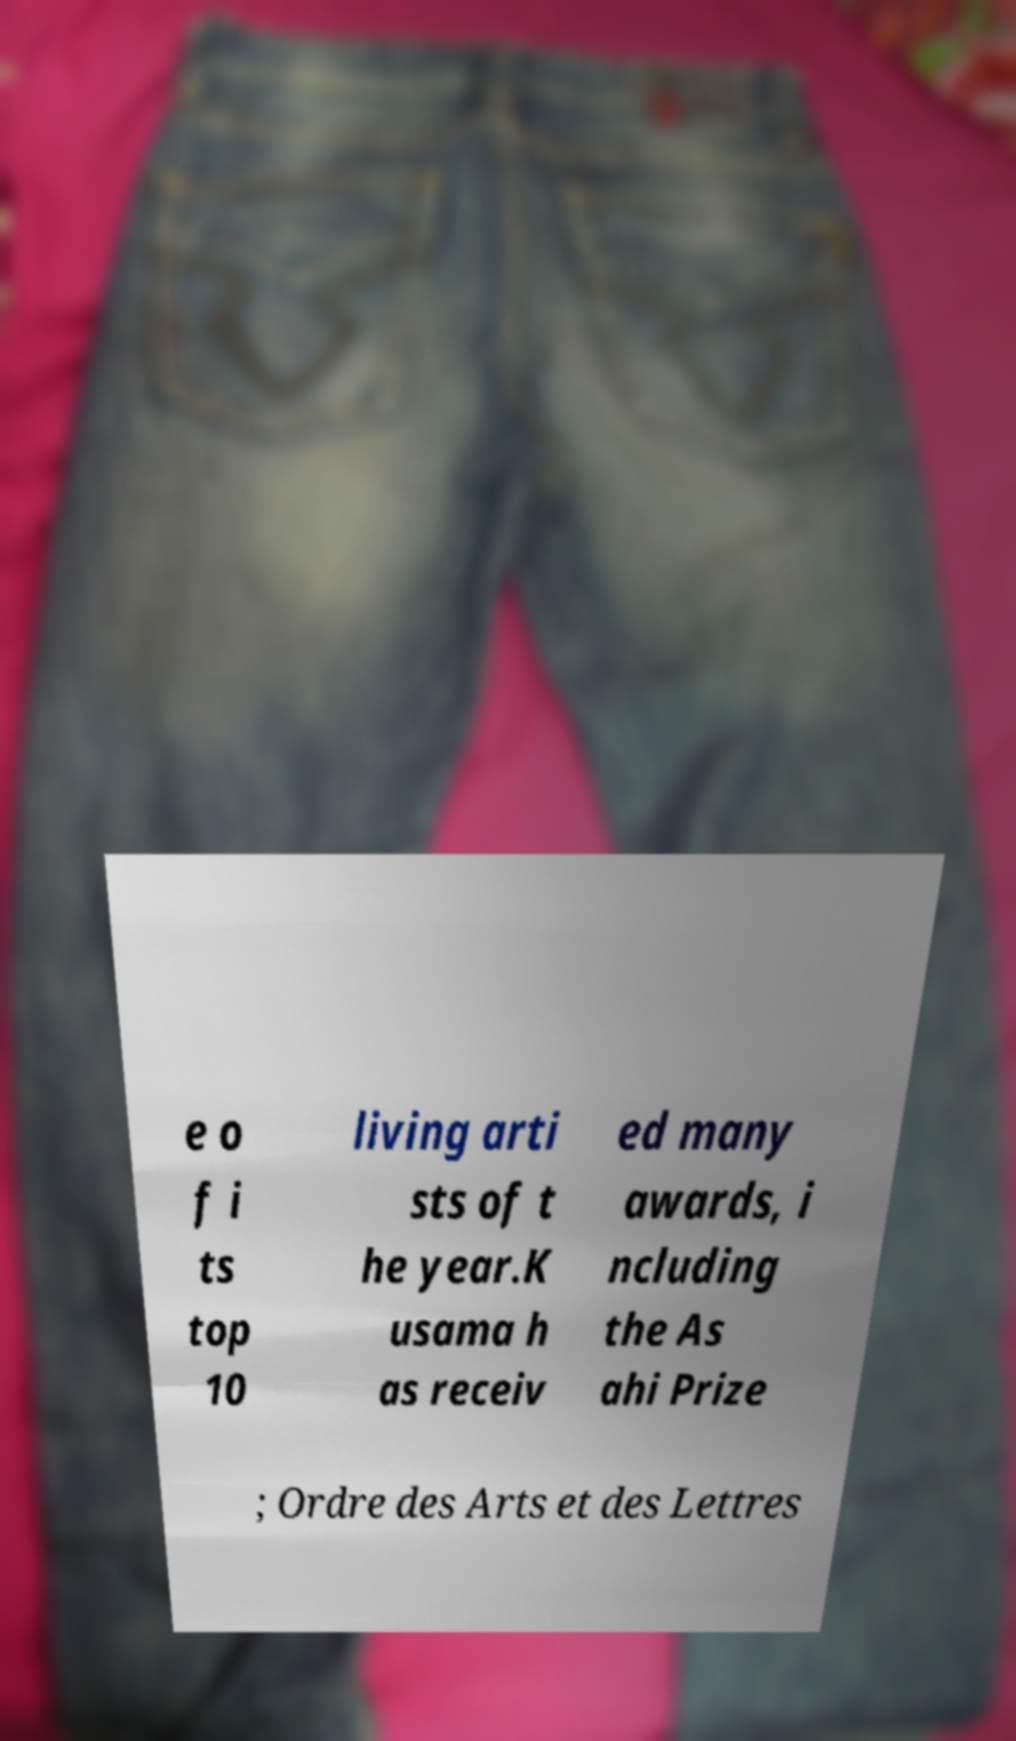Please identify and transcribe the text found in this image. e o f i ts top 10 living arti sts of t he year.K usama h as receiv ed many awards, i ncluding the As ahi Prize ; Ordre des Arts et des Lettres 